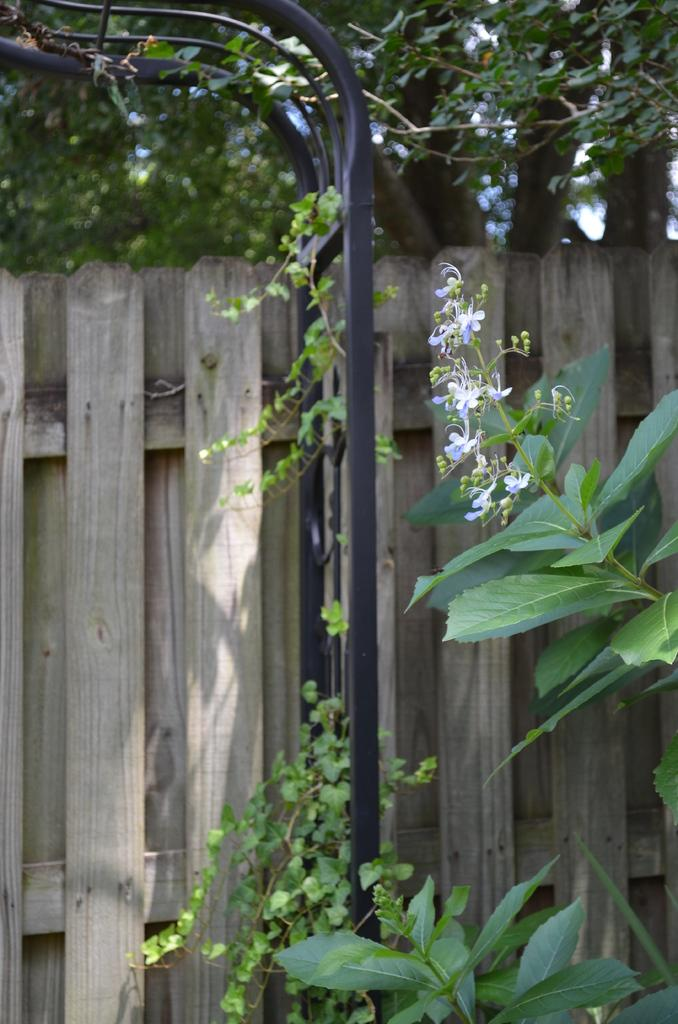What type of plant is on the right side of the image? There is a plant with small flowers on the right side of the image. What can be seen in the middle of the image? There are poles in the middle of the image. What is in the background of the image? There is a wooden fence and trees in the background of the image. What is visible at the top of the image? The sky is visible in the background of the image. What type of jelly is being used to decorate the poles in the image? There is no jelly present in the image; the poles are not decorated with any jelly. What type of quilt is draped over the wooden fence in the image? There is no quilt present in the image; the wooden fence is not draped with any quilt. 